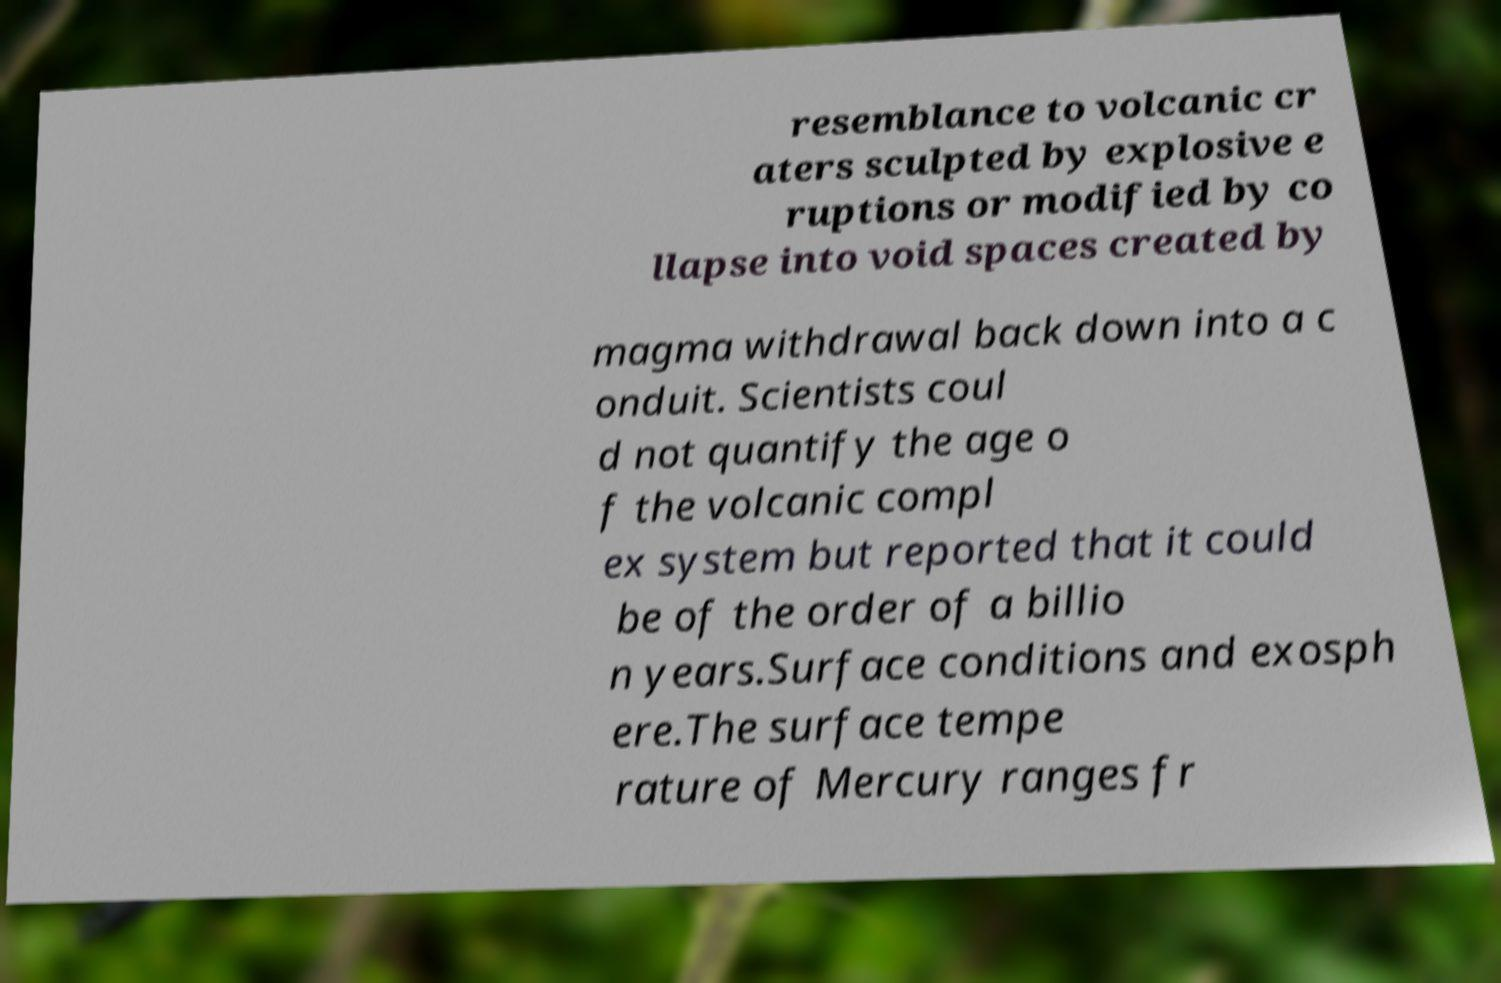For documentation purposes, I need the text within this image transcribed. Could you provide that? resemblance to volcanic cr aters sculpted by explosive e ruptions or modified by co llapse into void spaces created by magma withdrawal back down into a c onduit. Scientists coul d not quantify the age o f the volcanic compl ex system but reported that it could be of the order of a billio n years.Surface conditions and exosph ere.The surface tempe rature of Mercury ranges fr 